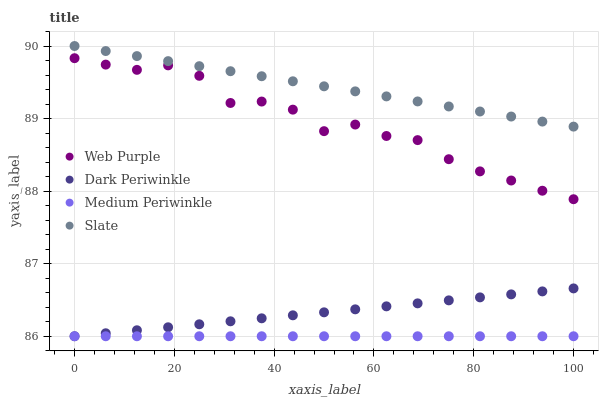Does Medium Periwinkle have the minimum area under the curve?
Answer yes or no. Yes. Does Slate have the maximum area under the curve?
Answer yes or no. Yes. Does Slate have the minimum area under the curve?
Answer yes or no. No. Does Medium Periwinkle have the maximum area under the curve?
Answer yes or no. No. Is Medium Periwinkle the smoothest?
Answer yes or no. Yes. Is Web Purple the roughest?
Answer yes or no. Yes. Is Slate the smoothest?
Answer yes or no. No. Is Slate the roughest?
Answer yes or no. No. Does Medium Periwinkle have the lowest value?
Answer yes or no. Yes. Does Slate have the lowest value?
Answer yes or no. No. Does Slate have the highest value?
Answer yes or no. Yes. Does Medium Periwinkle have the highest value?
Answer yes or no. No. Is Medium Periwinkle less than Web Purple?
Answer yes or no. Yes. Is Slate greater than Medium Periwinkle?
Answer yes or no. Yes. Does Dark Periwinkle intersect Medium Periwinkle?
Answer yes or no. Yes. Is Dark Periwinkle less than Medium Periwinkle?
Answer yes or no. No. Is Dark Periwinkle greater than Medium Periwinkle?
Answer yes or no. No. Does Medium Periwinkle intersect Web Purple?
Answer yes or no. No. 